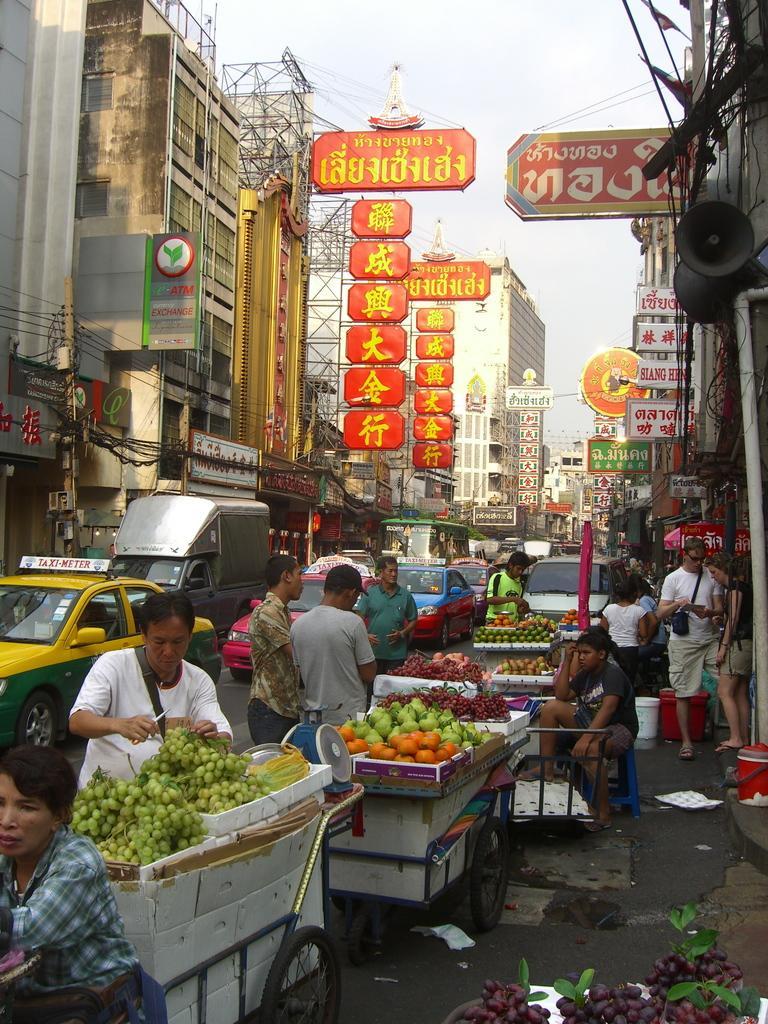How would you summarize this image in a sentence or two? This picture is clicked outside. In the foreground we can see the fruits, group of people, vehicles and many other objects. In the background we can see the sky, buildings, text on the boards and we can see many other objects. 